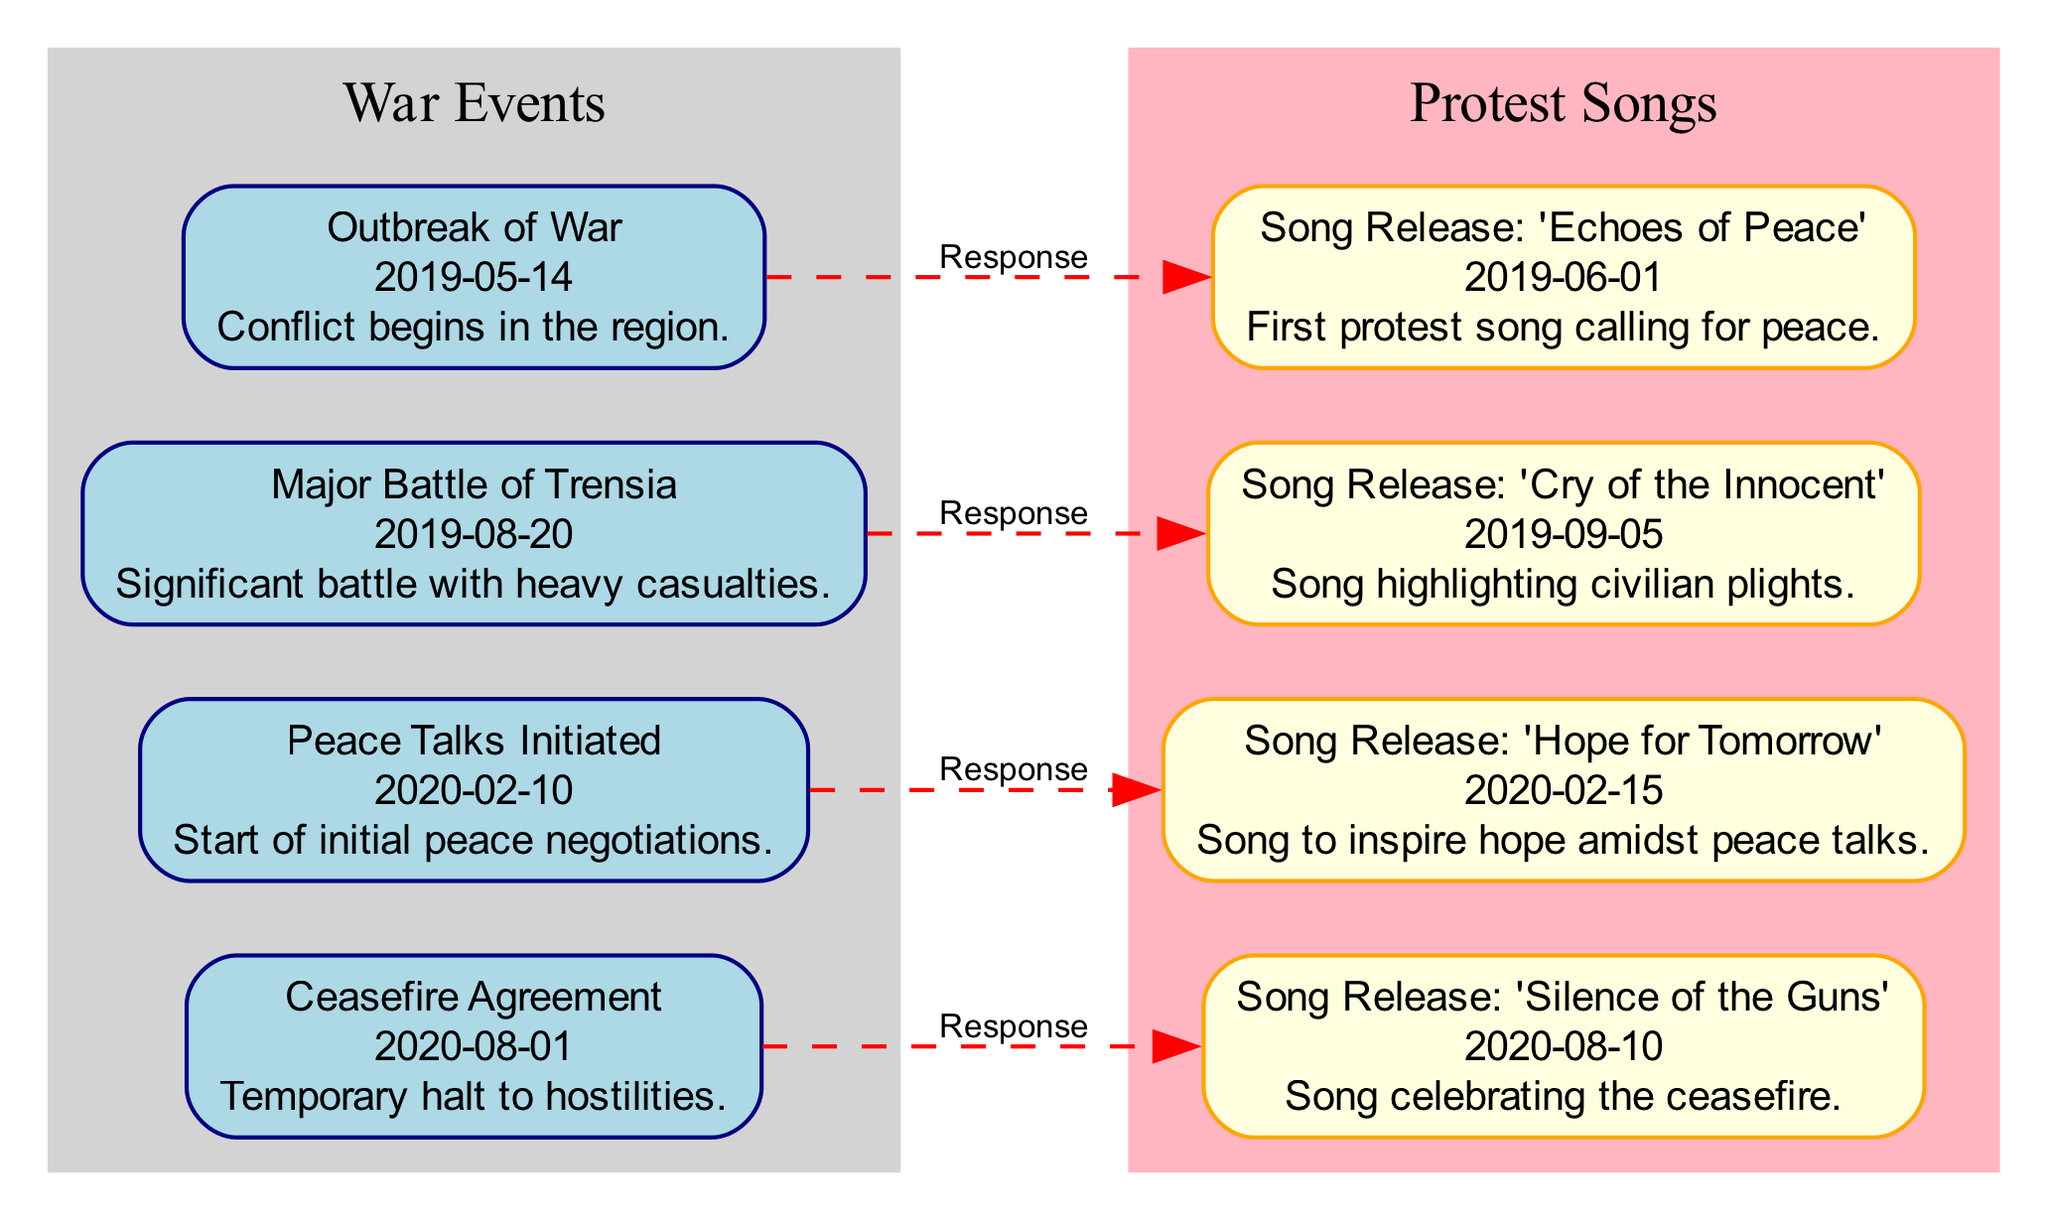What date marks the outbreak of war? The diagram shows that the outbreak of war is recorded on May 14, 2019, which is clearly labeled under the first event.
Answer: May 14, 2019 How many protest songs are released after the Major Battle of Trensia? The Major Battle of Trensia occurred on August 20, 2019, and there are two subsequent protest songs released thereafter; the song 'Cry of the Innocent' on September 5, 2019, and 'Hope for Tomorrow' on February 15, 2020.
Answer: 2 What does the song 'Silence of the Guns' celebrate? The diagram indicates that 'Silence of the Guns' which is released on August 10, 2020, is a song that celebrates the ceasefire agreement which was reached on August 1, 2020, linking it to the significant event it is responding to.
Answer: Ceasefire Which song was released first, 'Cry of the Innocent' or 'Hope for Tomorrow'? The diagram distinctly shows that 'Cry of the Innocent' was released on September 5, 2019, and 'Hope for Tomorrow' on February 15, 2020, hence 'Cry of the Innocent' is the earlier release.
Answer: Cry of the Innocent What is the relationship between 'Echoes of Peace' and the outbreak of war? According to the diagram, 'Echoes of Peace', released on June 1, 2019, is explicitly marked as a response to the outbreak of war which began on May 14, 2019, showing a direct connection between these events.
Answer: Response What significant event occurred on February 10, 2020? The diagram records that on February 10, 2020, the Peace Talks were initiated, marking a notable effort towards resolution in the timeline.
Answer: Peace Talks Initiated How many nodes represent protest songs in total? The diagram includes four songs labeled as protest songs, which are 'Echoes of Peace', 'Cry of the Innocent', 'Hope for Tomorrow', and 'Silence of the Guns', indicating the total number of song nodes.
Answer: 4 What is the label of the event following the Peace Talks? The diagram presents the event following the Peace Talks initiated on February 10, 2020, as the Ceasefire Agreement that took place on August 1, 2020, thereby categorizing the events of interest clearly in timeline order.
Answer: Ceasefire Agreement 